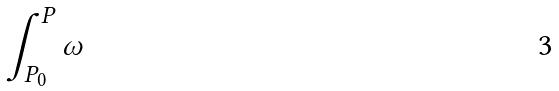<formula> <loc_0><loc_0><loc_500><loc_500>\int _ { P _ { 0 } } ^ { P } \omega</formula> 